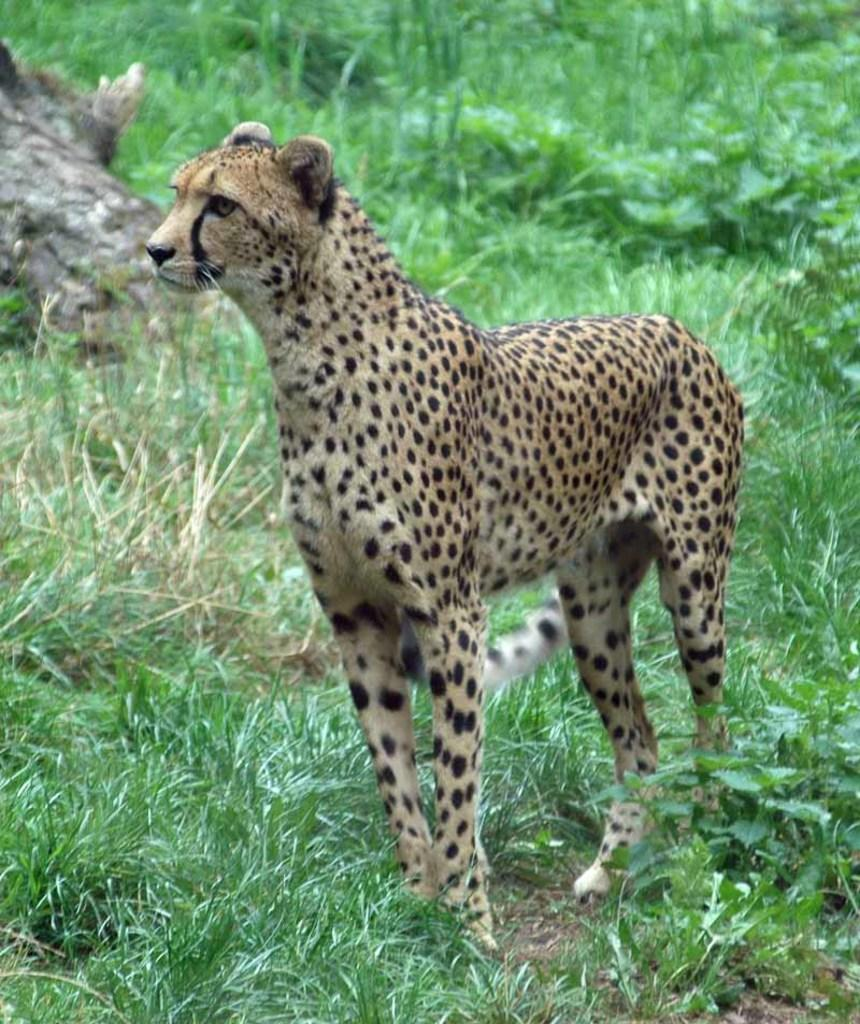What type of animal is in the image? There is an animal in the image, but the specific type cannot be determined from the provided facts. What colors are present on the animal? The animal has black and brown coloring. What can be seen in the background of the image? There are plants and grass in the background of the image. What color are the plants and grass? The plants and grass are green in color. What type of scarf is the animal wearing in the image? There is no scarf present in the image; the animal is not wearing any clothing. What financial interest does the animal have in the image? There is no indication of any financial interest in the image, as it features an animal and plants. 